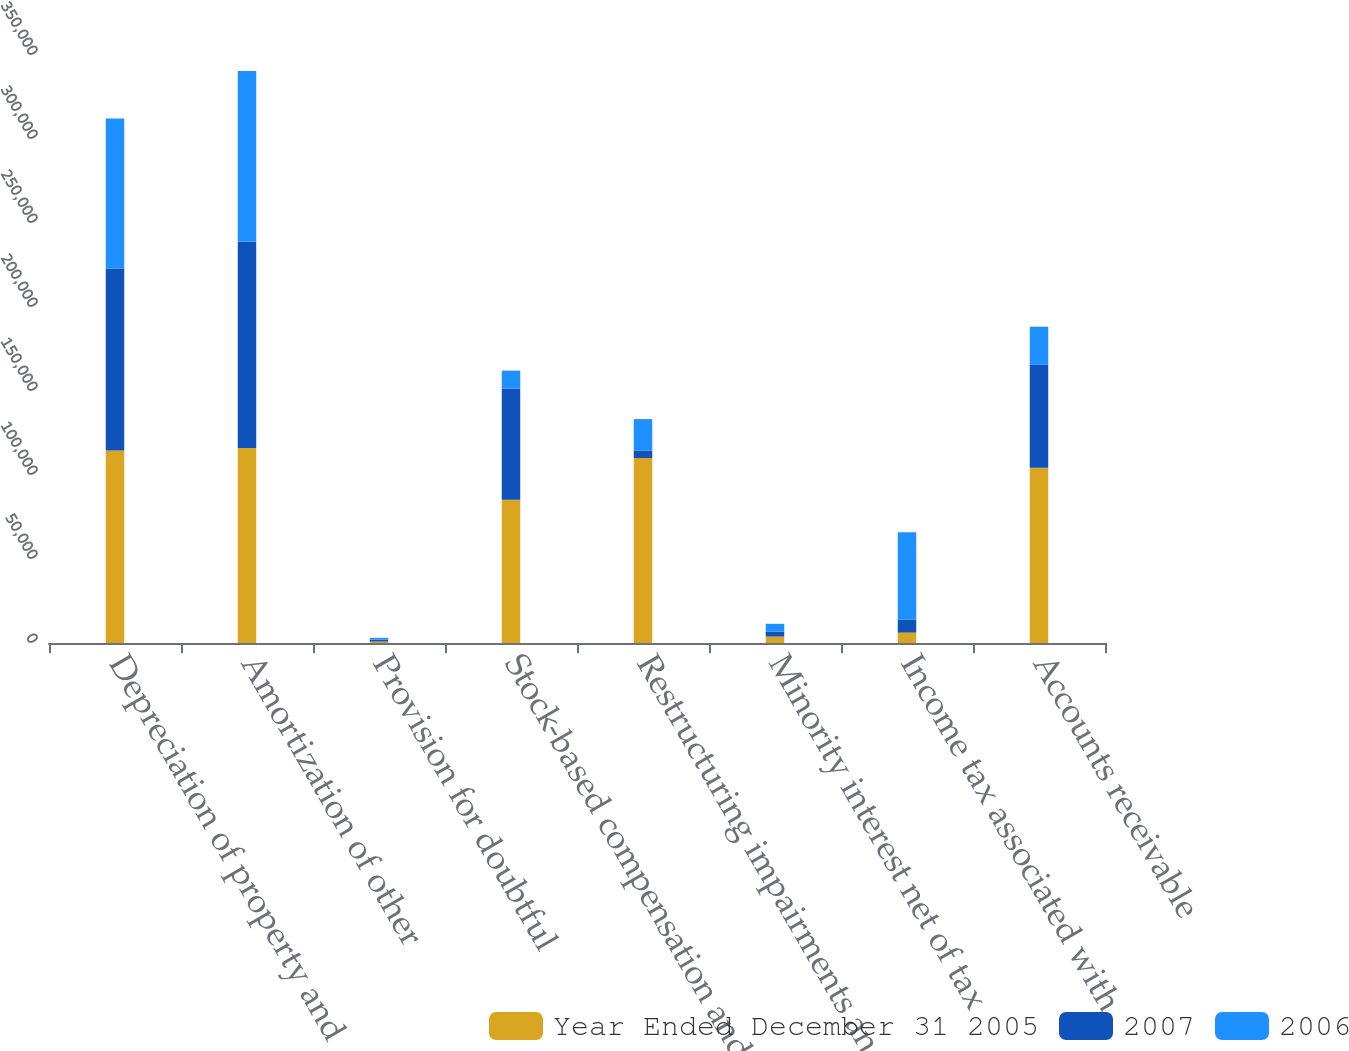Convert chart. <chart><loc_0><loc_0><loc_500><loc_500><stacked_bar_chart><ecel><fcel>Depreciation of property and<fcel>Amortization of other<fcel>Provision for doubtful<fcel>Stock-based compensation and<fcel>Restructuring impairments and<fcel>Minority interest net of tax<fcel>Income tax associated with<fcel>Accounts receivable<nl><fcel>Year Ended December 31 2005<fcel>114539<fcel>116064<fcel>850<fcel>85250<fcel>110110<fcel>3840<fcel>6189<fcel>104338<nl><fcel>2007<fcel>108349<fcel>122767<fcel>1165<fcel>66285<fcel>4471<fcel>2875<fcel>7833<fcel>61263<nl><fcel>2006<fcel>89309<fcel>101638<fcel>1041<fcel>10588<fcel>18703<fcel>4702<fcel>51964<fcel>22665<nl></chart> 